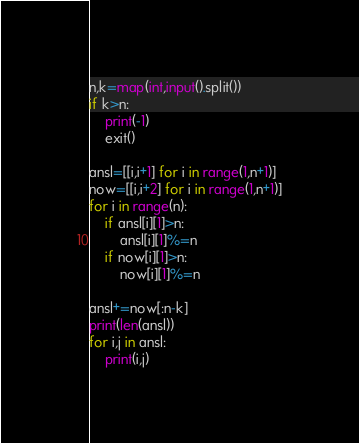<code> <loc_0><loc_0><loc_500><loc_500><_Python_>n,k=map(int,input().split())
if k>n:
    print(-1)
    exit()

ansl=[[i,i+1] for i in range(1,n+1)]
now=[[i,i+2] for i in range(1,n+1)]
for i in range(n):
    if ansl[i][1]>n:
        ansl[i][1]%=n
    if now[i][1]>n:
        now[i][1]%=n

ansl+=now[:n-k]
print(len(ansl))
for i,j in ansl:
    print(i,j)
</code> 